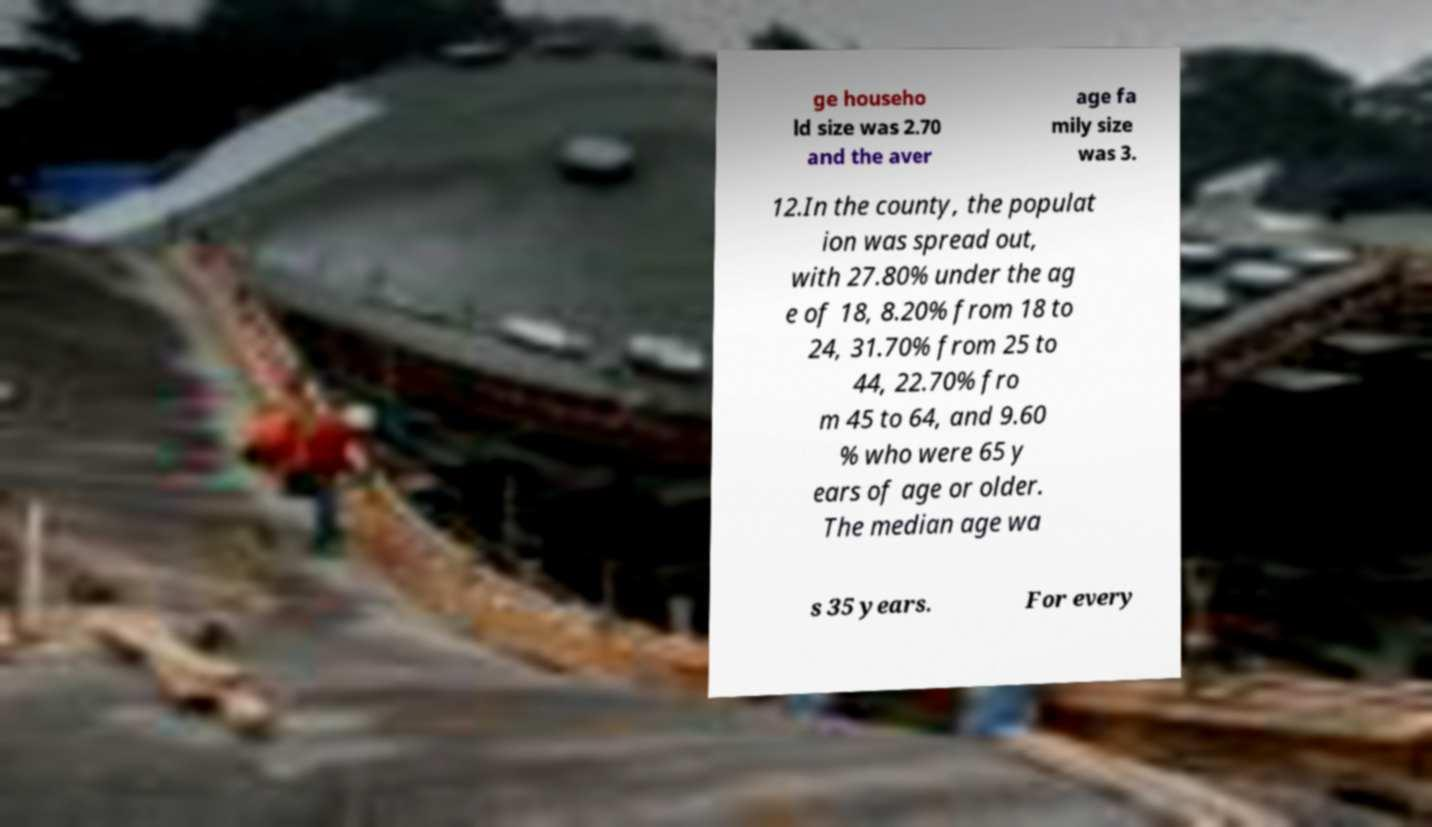Could you extract and type out the text from this image? ge househo ld size was 2.70 and the aver age fa mily size was 3. 12.In the county, the populat ion was spread out, with 27.80% under the ag e of 18, 8.20% from 18 to 24, 31.70% from 25 to 44, 22.70% fro m 45 to 64, and 9.60 % who were 65 y ears of age or older. The median age wa s 35 years. For every 